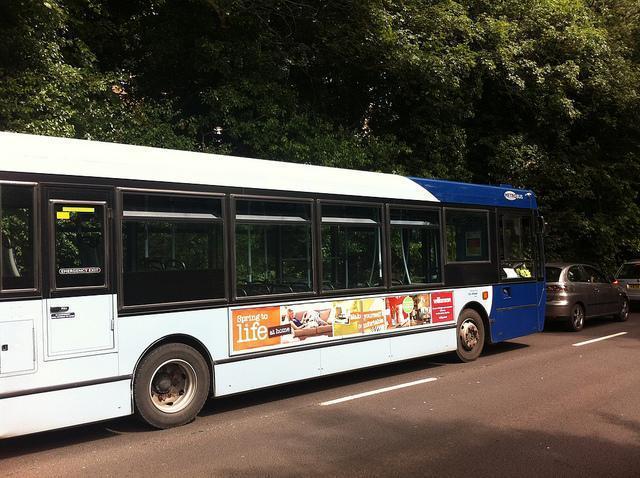How many buses?
Give a very brief answer. 1. 